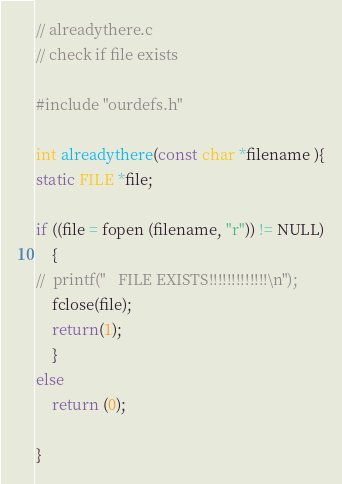Convert code to text. <code><loc_0><loc_0><loc_500><loc_500><_C_>// alreadythere.c
// check if file exists

#include "ourdefs.h"

int alreadythere(const char *filename ){
static FILE *file;

if ((file = fopen (filename, "r")) != NULL)
	{
//	printf("   FILE EXISTS!!!!!!!!!!!!!\n");
	fclose(file);
	return(1);
	}
else
	return (0);

}
</code> 